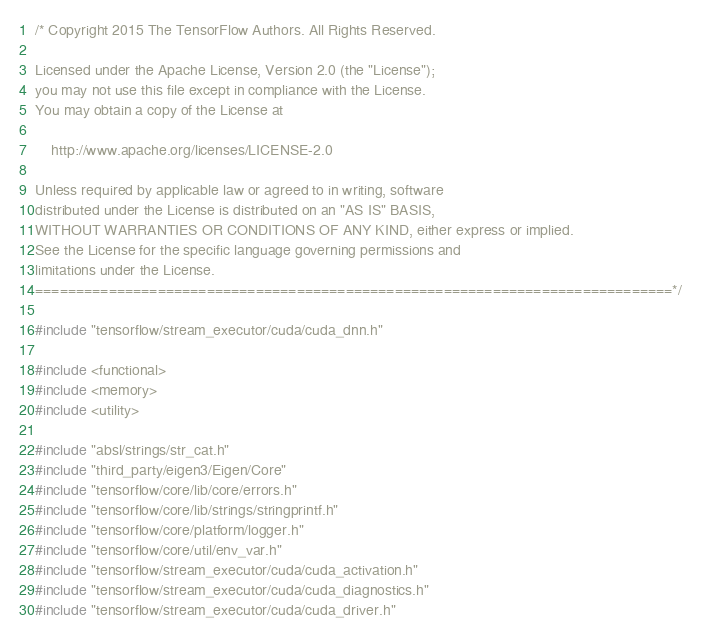<code> <loc_0><loc_0><loc_500><loc_500><_C++_>/* Copyright 2015 The TensorFlow Authors. All Rights Reserved.

Licensed under the Apache License, Version 2.0 (the "License");
you may not use this file except in compliance with the License.
You may obtain a copy of the License at

    http://www.apache.org/licenses/LICENSE-2.0

Unless required by applicable law or agreed to in writing, software
distributed under the License is distributed on an "AS IS" BASIS,
WITHOUT WARRANTIES OR CONDITIONS OF ANY KIND, either express or implied.
See the License for the specific language governing permissions and
limitations under the License.
==============================================================================*/

#include "tensorflow/stream_executor/cuda/cuda_dnn.h"

#include <functional>
#include <memory>
#include <utility>

#include "absl/strings/str_cat.h"
#include "third_party/eigen3/Eigen/Core"
#include "tensorflow/core/lib/core/errors.h"
#include "tensorflow/core/lib/strings/stringprintf.h"
#include "tensorflow/core/platform/logger.h"
#include "tensorflow/core/util/env_var.h"
#include "tensorflow/stream_executor/cuda/cuda_activation.h"
#include "tensorflow/stream_executor/cuda/cuda_diagnostics.h"
#include "tensorflow/stream_executor/cuda/cuda_driver.h"</code> 